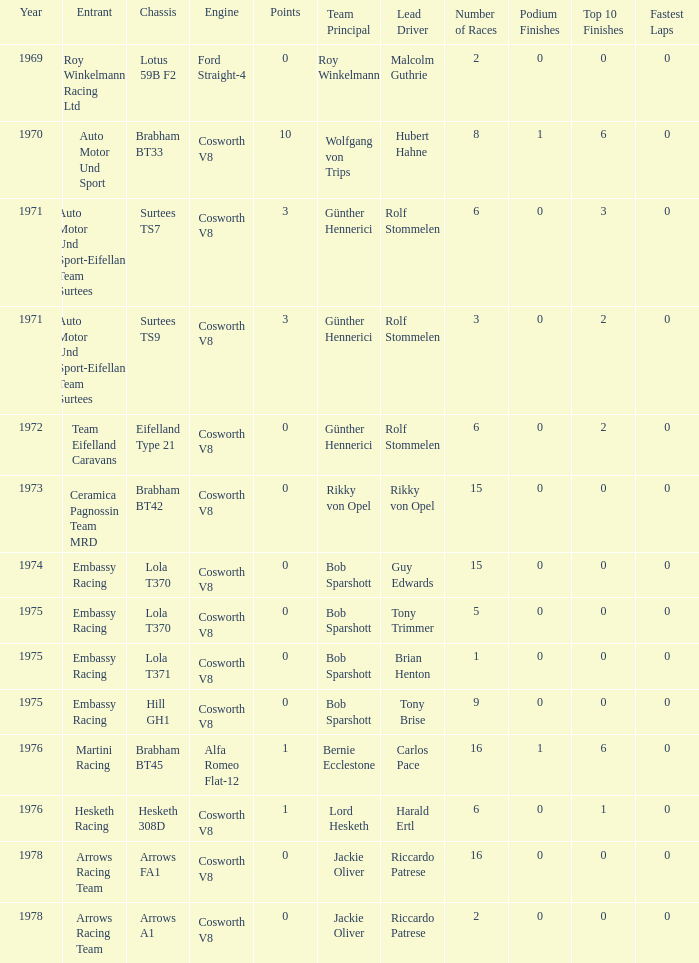In 1970, what entrant had a cosworth v8 engine? Auto Motor Und Sport. 